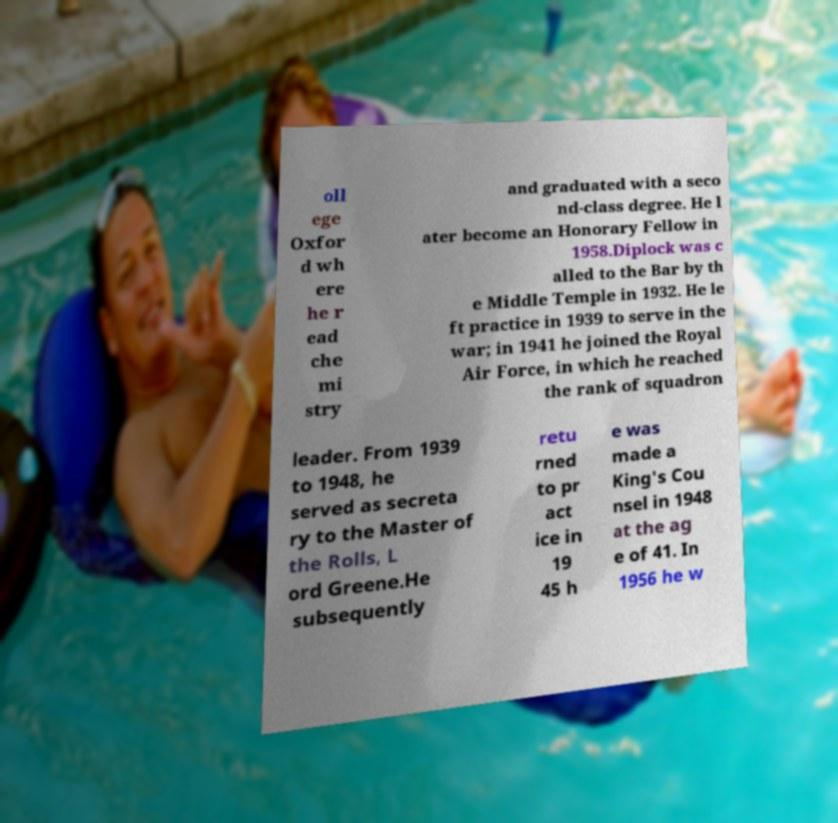What messages or text are displayed in this image? I need them in a readable, typed format. oll ege Oxfor d wh ere he r ead che mi stry and graduated with a seco nd-class degree. He l ater become an Honorary Fellow in 1958.Diplock was c alled to the Bar by th e Middle Temple in 1932. He le ft practice in 1939 to serve in the war; in 1941 he joined the Royal Air Force, in which he reached the rank of squadron leader. From 1939 to 1948, he served as secreta ry to the Master of the Rolls, L ord Greene.He subsequently retu rned to pr act ice in 19 45 h e was made a King's Cou nsel in 1948 at the ag e of 41. In 1956 he w 